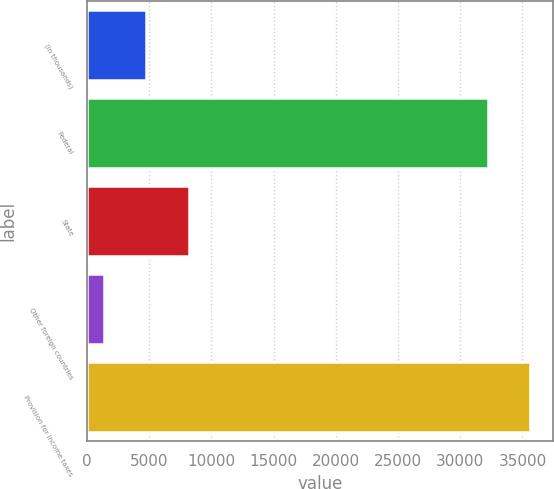Convert chart to OTSL. <chart><loc_0><loc_0><loc_500><loc_500><bar_chart><fcel>(In thousands)<fcel>Federal<fcel>State<fcel>Other foreign countries<fcel>Provision for income taxes<nl><fcel>4773.8<fcel>32215<fcel>8202.6<fcel>1345<fcel>35643.8<nl></chart> 